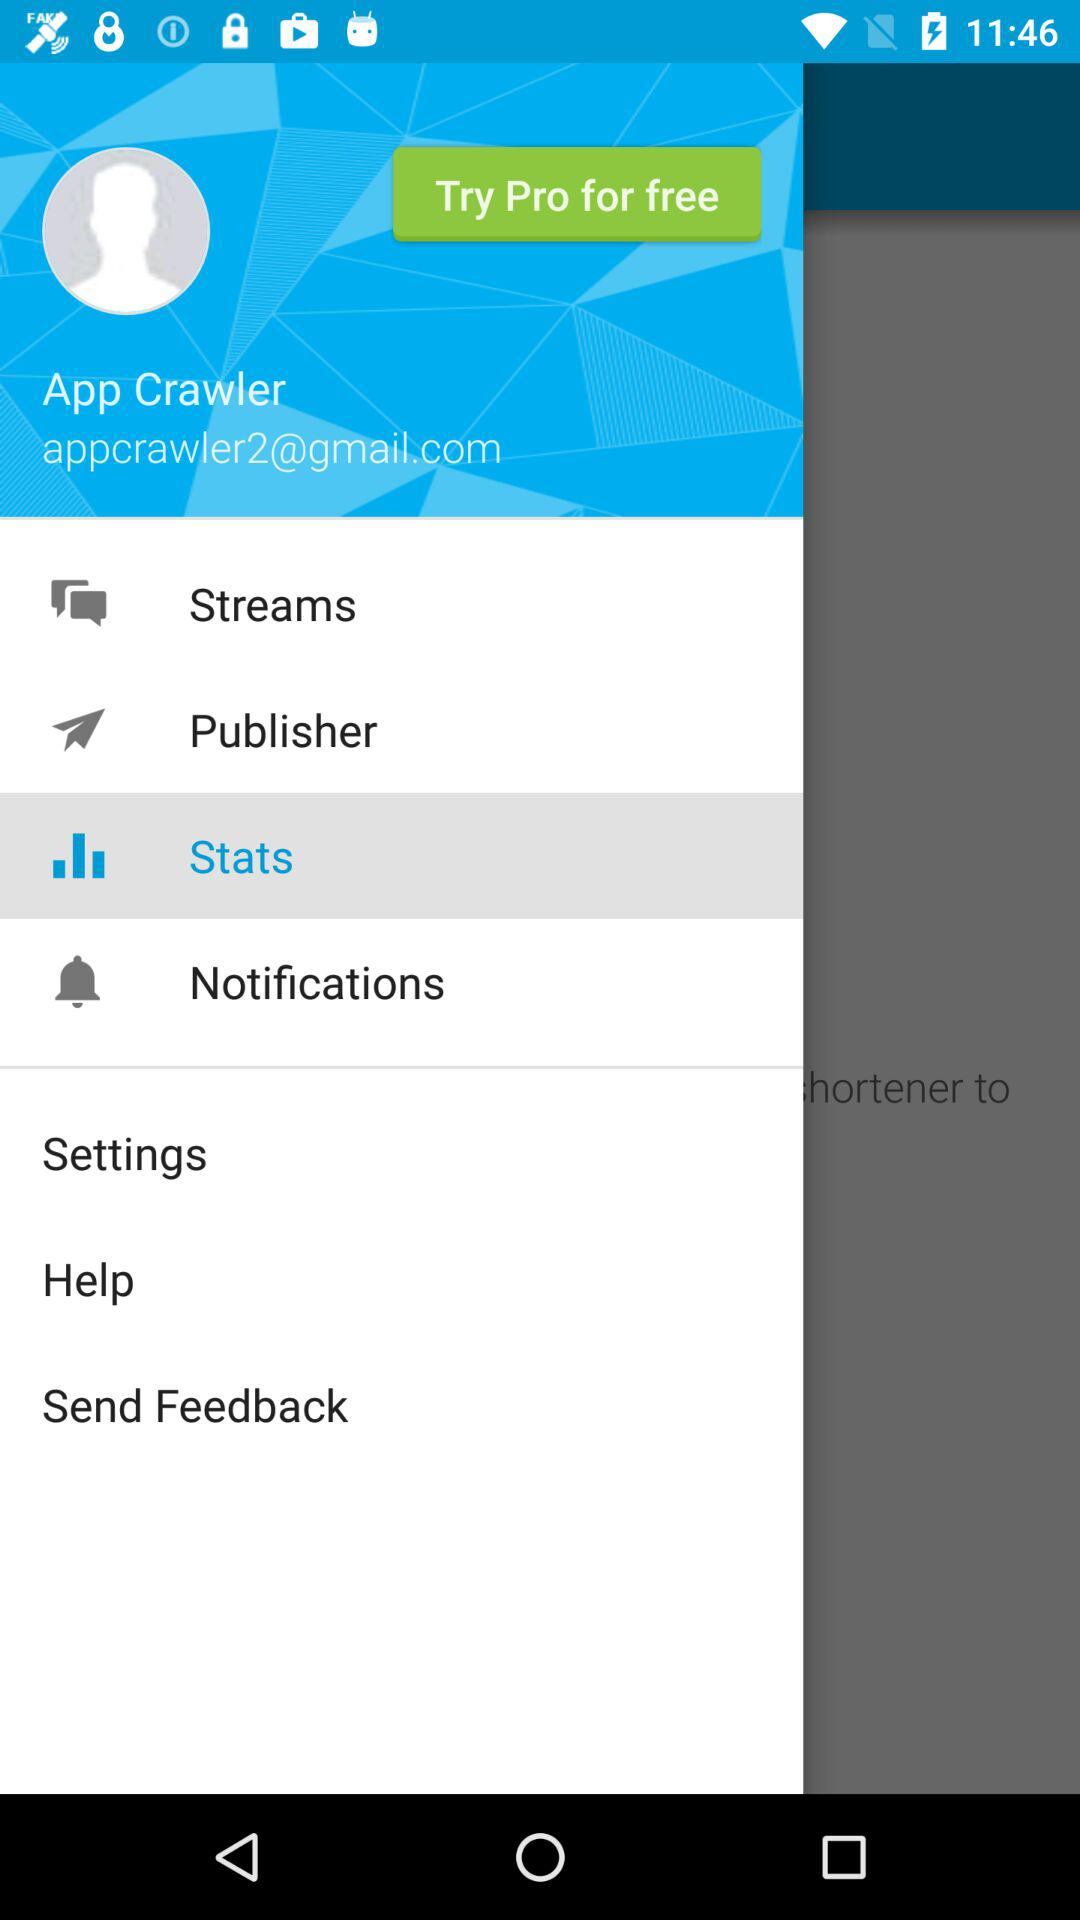What is the email address? The email address is appcrawler2@gmail.com. 